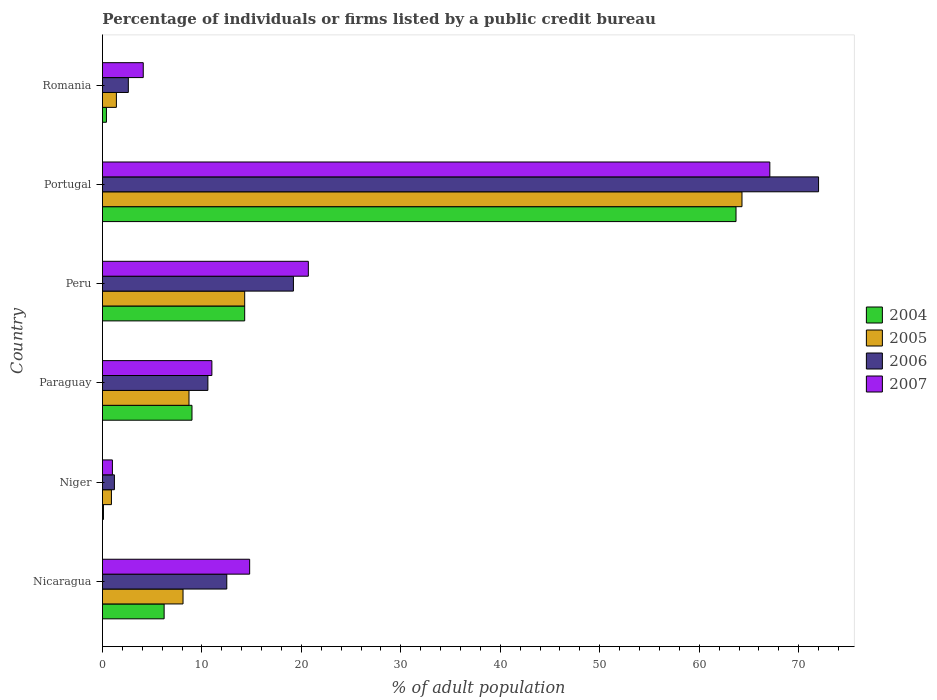How many different coloured bars are there?
Ensure brevity in your answer.  4. Are the number of bars on each tick of the Y-axis equal?
Offer a very short reply. Yes. How many bars are there on the 1st tick from the top?
Offer a terse response. 4. What is the label of the 6th group of bars from the top?
Offer a terse response. Nicaragua. In how many cases, is the number of bars for a given country not equal to the number of legend labels?
Offer a terse response. 0. What is the percentage of population listed by a public credit bureau in 2005 in Peru?
Your response must be concise. 14.3. In which country was the percentage of population listed by a public credit bureau in 2007 maximum?
Provide a succinct answer. Portugal. In which country was the percentage of population listed by a public credit bureau in 2004 minimum?
Make the answer very short. Niger. What is the total percentage of population listed by a public credit bureau in 2005 in the graph?
Provide a succinct answer. 97.7. What is the difference between the percentage of population listed by a public credit bureau in 2005 in Paraguay and that in Romania?
Make the answer very short. 7.3. What is the average percentage of population listed by a public credit bureau in 2006 per country?
Provide a succinct answer. 19.68. What is the difference between the percentage of population listed by a public credit bureau in 2007 and percentage of population listed by a public credit bureau in 2006 in Peru?
Your answer should be compact. 1.5. In how many countries, is the percentage of population listed by a public credit bureau in 2006 greater than 72 %?
Provide a succinct answer. 0. What is the ratio of the percentage of population listed by a public credit bureau in 2004 in Niger to that in Peru?
Your response must be concise. 0.01. What is the difference between the highest and the lowest percentage of population listed by a public credit bureau in 2005?
Ensure brevity in your answer.  63.4. How many bars are there?
Offer a very short reply. 24. Are all the bars in the graph horizontal?
Your answer should be compact. Yes. What is the difference between two consecutive major ticks on the X-axis?
Offer a terse response. 10. Are the values on the major ticks of X-axis written in scientific E-notation?
Your answer should be very brief. No. Does the graph contain any zero values?
Offer a terse response. No. Does the graph contain grids?
Your response must be concise. No. How many legend labels are there?
Make the answer very short. 4. How are the legend labels stacked?
Provide a succinct answer. Vertical. What is the title of the graph?
Your answer should be very brief. Percentage of individuals or firms listed by a public credit bureau. Does "1987" appear as one of the legend labels in the graph?
Ensure brevity in your answer.  No. What is the label or title of the X-axis?
Provide a short and direct response. % of adult population. What is the % of adult population in 2004 in Nicaragua?
Your answer should be very brief. 6.2. What is the % of adult population of 2005 in Nicaragua?
Give a very brief answer. 8.1. What is the % of adult population of 2007 in Nicaragua?
Your response must be concise. 14.8. What is the % of adult population in 2004 in Niger?
Make the answer very short. 0.1. What is the % of adult population of 2005 in Niger?
Ensure brevity in your answer.  0.9. What is the % of adult population in 2007 in Niger?
Give a very brief answer. 1. What is the % of adult population of 2007 in Paraguay?
Give a very brief answer. 11. What is the % of adult population of 2004 in Peru?
Offer a very short reply. 14.3. What is the % of adult population of 2005 in Peru?
Ensure brevity in your answer.  14.3. What is the % of adult population of 2007 in Peru?
Your answer should be compact. 20.7. What is the % of adult population of 2004 in Portugal?
Make the answer very short. 63.7. What is the % of adult population of 2005 in Portugal?
Make the answer very short. 64.3. What is the % of adult population of 2006 in Portugal?
Provide a short and direct response. 72. What is the % of adult population of 2007 in Portugal?
Your answer should be compact. 67.1. Across all countries, what is the maximum % of adult population of 2004?
Provide a succinct answer. 63.7. Across all countries, what is the maximum % of adult population of 2005?
Your answer should be very brief. 64.3. Across all countries, what is the maximum % of adult population in 2007?
Make the answer very short. 67.1. Across all countries, what is the minimum % of adult population in 2004?
Make the answer very short. 0.1. What is the total % of adult population in 2004 in the graph?
Provide a succinct answer. 93.7. What is the total % of adult population in 2005 in the graph?
Your answer should be very brief. 97.7. What is the total % of adult population of 2006 in the graph?
Offer a very short reply. 118.1. What is the total % of adult population in 2007 in the graph?
Your answer should be compact. 118.7. What is the difference between the % of adult population in 2005 in Nicaragua and that in Niger?
Your answer should be very brief. 7.2. What is the difference between the % of adult population of 2006 in Nicaragua and that in Niger?
Your answer should be compact. 11.3. What is the difference between the % of adult population in 2007 in Nicaragua and that in Niger?
Provide a short and direct response. 13.8. What is the difference between the % of adult population of 2004 in Nicaragua and that in Paraguay?
Your answer should be very brief. -2.8. What is the difference between the % of adult population in 2005 in Nicaragua and that in Paraguay?
Your response must be concise. -0.6. What is the difference between the % of adult population in 2006 in Nicaragua and that in Paraguay?
Your response must be concise. 1.9. What is the difference between the % of adult population in 2004 in Nicaragua and that in Peru?
Your answer should be very brief. -8.1. What is the difference between the % of adult population of 2006 in Nicaragua and that in Peru?
Your answer should be compact. -6.7. What is the difference between the % of adult population of 2004 in Nicaragua and that in Portugal?
Keep it short and to the point. -57.5. What is the difference between the % of adult population of 2005 in Nicaragua and that in Portugal?
Offer a very short reply. -56.2. What is the difference between the % of adult population in 2006 in Nicaragua and that in Portugal?
Make the answer very short. -59.5. What is the difference between the % of adult population in 2007 in Nicaragua and that in Portugal?
Give a very brief answer. -52.3. What is the difference between the % of adult population of 2004 in Nicaragua and that in Romania?
Ensure brevity in your answer.  5.8. What is the difference between the % of adult population of 2005 in Nicaragua and that in Romania?
Your response must be concise. 6.7. What is the difference between the % of adult population in 2006 in Nicaragua and that in Romania?
Your response must be concise. 9.9. What is the difference between the % of adult population of 2004 in Niger and that in Paraguay?
Give a very brief answer. -8.9. What is the difference between the % of adult population in 2006 in Niger and that in Paraguay?
Offer a terse response. -9.4. What is the difference between the % of adult population in 2006 in Niger and that in Peru?
Keep it short and to the point. -18. What is the difference between the % of adult population of 2007 in Niger and that in Peru?
Make the answer very short. -19.7. What is the difference between the % of adult population of 2004 in Niger and that in Portugal?
Provide a short and direct response. -63.6. What is the difference between the % of adult population of 2005 in Niger and that in Portugal?
Provide a succinct answer. -63.4. What is the difference between the % of adult population of 2006 in Niger and that in Portugal?
Ensure brevity in your answer.  -70.8. What is the difference between the % of adult population of 2007 in Niger and that in Portugal?
Keep it short and to the point. -66.1. What is the difference between the % of adult population in 2004 in Niger and that in Romania?
Offer a terse response. -0.3. What is the difference between the % of adult population in 2005 in Niger and that in Romania?
Make the answer very short. -0.5. What is the difference between the % of adult population in 2006 in Niger and that in Romania?
Ensure brevity in your answer.  -1.4. What is the difference between the % of adult population of 2007 in Niger and that in Romania?
Your answer should be very brief. -3.1. What is the difference between the % of adult population in 2006 in Paraguay and that in Peru?
Keep it short and to the point. -8.6. What is the difference between the % of adult population of 2007 in Paraguay and that in Peru?
Make the answer very short. -9.7. What is the difference between the % of adult population in 2004 in Paraguay and that in Portugal?
Make the answer very short. -54.7. What is the difference between the % of adult population in 2005 in Paraguay and that in Portugal?
Provide a succinct answer. -55.6. What is the difference between the % of adult population in 2006 in Paraguay and that in Portugal?
Give a very brief answer. -61.4. What is the difference between the % of adult population in 2007 in Paraguay and that in Portugal?
Keep it short and to the point. -56.1. What is the difference between the % of adult population of 2005 in Paraguay and that in Romania?
Your answer should be compact. 7.3. What is the difference between the % of adult population of 2007 in Paraguay and that in Romania?
Your response must be concise. 6.9. What is the difference between the % of adult population of 2004 in Peru and that in Portugal?
Offer a terse response. -49.4. What is the difference between the % of adult population in 2006 in Peru and that in Portugal?
Your answer should be compact. -52.8. What is the difference between the % of adult population of 2007 in Peru and that in Portugal?
Offer a terse response. -46.4. What is the difference between the % of adult population of 2005 in Peru and that in Romania?
Offer a terse response. 12.9. What is the difference between the % of adult population of 2007 in Peru and that in Romania?
Offer a very short reply. 16.6. What is the difference between the % of adult population in 2004 in Portugal and that in Romania?
Offer a very short reply. 63.3. What is the difference between the % of adult population of 2005 in Portugal and that in Romania?
Ensure brevity in your answer.  62.9. What is the difference between the % of adult population in 2006 in Portugal and that in Romania?
Offer a very short reply. 69.4. What is the difference between the % of adult population of 2004 in Nicaragua and the % of adult population of 2005 in Niger?
Offer a terse response. 5.3. What is the difference between the % of adult population of 2004 in Nicaragua and the % of adult population of 2006 in Niger?
Provide a succinct answer. 5. What is the difference between the % of adult population of 2004 in Nicaragua and the % of adult population of 2007 in Niger?
Your answer should be very brief. 5.2. What is the difference between the % of adult population of 2004 in Nicaragua and the % of adult population of 2005 in Paraguay?
Your response must be concise. -2.5. What is the difference between the % of adult population of 2004 in Nicaragua and the % of adult population of 2007 in Paraguay?
Ensure brevity in your answer.  -4.8. What is the difference between the % of adult population in 2005 in Nicaragua and the % of adult population in 2007 in Paraguay?
Offer a terse response. -2.9. What is the difference between the % of adult population of 2004 in Nicaragua and the % of adult population of 2005 in Peru?
Offer a very short reply. -8.1. What is the difference between the % of adult population of 2004 in Nicaragua and the % of adult population of 2006 in Peru?
Ensure brevity in your answer.  -13. What is the difference between the % of adult population of 2005 in Nicaragua and the % of adult population of 2006 in Peru?
Give a very brief answer. -11.1. What is the difference between the % of adult population in 2005 in Nicaragua and the % of adult population in 2007 in Peru?
Offer a very short reply. -12.6. What is the difference between the % of adult population in 2004 in Nicaragua and the % of adult population in 2005 in Portugal?
Provide a short and direct response. -58.1. What is the difference between the % of adult population of 2004 in Nicaragua and the % of adult population of 2006 in Portugal?
Offer a very short reply. -65.8. What is the difference between the % of adult population of 2004 in Nicaragua and the % of adult population of 2007 in Portugal?
Your response must be concise. -60.9. What is the difference between the % of adult population in 2005 in Nicaragua and the % of adult population in 2006 in Portugal?
Provide a short and direct response. -63.9. What is the difference between the % of adult population of 2005 in Nicaragua and the % of adult population of 2007 in Portugal?
Offer a terse response. -59. What is the difference between the % of adult population of 2006 in Nicaragua and the % of adult population of 2007 in Portugal?
Offer a terse response. -54.6. What is the difference between the % of adult population in 2004 in Nicaragua and the % of adult population in 2005 in Romania?
Your answer should be compact. 4.8. What is the difference between the % of adult population of 2005 in Nicaragua and the % of adult population of 2006 in Romania?
Offer a very short reply. 5.5. What is the difference between the % of adult population of 2005 in Nicaragua and the % of adult population of 2007 in Romania?
Give a very brief answer. 4. What is the difference between the % of adult population of 2006 in Nicaragua and the % of adult population of 2007 in Romania?
Offer a very short reply. 8.4. What is the difference between the % of adult population in 2004 in Niger and the % of adult population in 2006 in Paraguay?
Ensure brevity in your answer.  -10.5. What is the difference between the % of adult population of 2004 in Niger and the % of adult population of 2007 in Paraguay?
Offer a terse response. -10.9. What is the difference between the % of adult population in 2005 in Niger and the % of adult population in 2007 in Paraguay?
Provide a short and direct response. -10.1. What is the difference between the % of adult population in 2006 in Niger and the % of adult population in 2007 in Paraguay?
Your response must be concise. -9.8. What is the difference between the % of adult population in 2004 in Niger and the % of adult population in 2005 in Peru?
Provide a short and direct response. -14.2. What is the difference between the % of adult population of 2004 in Niger and the % of adult population of 2006 in Peru?
Offer a very short reply. -19.1. What is the difference between the % of adult population of 2004 in Niger and the % of adult population of 2007 in Peru?
Provide a succinct answer. -20.6. What is the difference between the % of adult population of 2005 in Niger and the % of adult population of 2006 in Peru?
Offer a terse response. -18.3. What is the difference between the % of adult population of 2005 in Niger and the % of adult population of 2007 in Peru?
Your response must be concise. -19.8. What is the difference between the % of adult population of 2006 in Niger and the % of adult population of 2007 in Peru?
Offer a very short reply. -19.5. What is the difference between the % of adult population of 2004 in Niger and the % of adult population of 2005 in Portugal?
Provide a short and direct response. -64.2. What is the difference between the % of adult population in 2004 in Niger and the % of adult population in 2006 in Portugal?
Ensure brevity in your answer.  -71.9. What is the difference between the % of adult population in 2004 in Niger and the % of adult population in 2007 in Portugal?
Your answer should be compact. -67. What is the difference between the % of adult population of 2005 in Niger and the % of adult population of 2006 in Portugal?
Keep it short and to the point. -71.1. What is the difference between the % of adult population in 2005 in Niger and the % of adult population in 2007 in Portugal?
Make the answer very short. -66.2. What is the difference between the % of adult population in 2006 in Niger and the % of adult population in 2007 in Portugal?
Ensure brevity in your answer.  -65.9. What is the difference between the % of adult population of 2004 in Niger and the % of adult population of 2007 in Romania?
Ensure brevity in your answer.  -4. What is the difference between the % of adult population of 2005 in Niger and the % of adult population of 2006 in Romania?
Keep it short and to the point. -1.7. What is the difference between the % of adult population of 2004 in Paraguay and the % of adult population of 2005 in Peru?
Your answer should be compact. -5.3. What is the difference between the % of adult population in 2005 in Paraguay and the % of adult population in 2007 in Peru?
Your answer should be very brief. -12. What is the difference between the % of adult population of 2006 in Paraguay and the % of adult population of 2007 in Peru?
Offer a very short reply. -10.1. What is the difference between the % of adult population in 2004 in Paraguay and the % of adult population in 2005 in Portugal?
Keep it short and to the point. -55.3. What is the difference between the % of adult population in 2004 in Paraguay and the % of adult population in 2006 in Portugal?
Your response must be concise. -63. What is the difference between the % of adult population of 2004 in Paraguay and the % of adult population of 2007 in Portugal?
Your answer should be very brief. -58.1. What is the difference between the % of adult population of 2005 in Paraguay and the % of adult population of 2006 in Portugal?
Make the answer very short. -63.3. What is the difference between the % of adult population in 2005 in Paraguay and the % of adult population in 2007 in Portugal?
Your answer should be compact. -58.4. What is the difference between the % of adult population of 2006 in Paraguay and the % of adult population of 2007 in Portugal?
Offer a very short reply. -56.5. What is the difference between the % of adult population of 2004 in Paraguay and the % of adult population of 2005 in Romania?
Ensure brevity in your answer.  7.6. What is the difference between the % of adult population in 2004 in Paraguay and the % of adult population in 2007 in Romania?
Offer a terse response. 4.9. What is the difference between the % of adult population of 2005 in Paraguay and the % of adult population of 2006 in Romania?
Provide a succinct answer. 6.1. What is the difference between the % of adult population in 2006 in Paraguay and the % of adult population in 2007 in Romania?
Give a very brief answer. 6.5. What is the difference between the % of adult population in 2004 in Peru and the % of adult population in 2005 in Portugal?
Provide a short and direct response. -50. What is the difference between the % of adult population of 2004 in Peru and the % of adult population of 2006 in Portugal?
Your answer should be compact. -57.7. What is the difference between the % of adult population in 2004 in Peru and the % of adult population in 2007 in Portugal?
Provide a short and direct response. -52.8. What is the difference between the % of adult population of 2005 in Peru and the % of adult population of 2006 in Portugal?
Ensure brevity in your answer.  -57.7. What is the difference between the % of adult population in 2005 in Peru and the % of adult population in 2007 in Portugal?
Offer a terse response. -52.8. What is the difference between the % of adult population in 2006 in Peru and the % of adult population in 2007 in Portugal?
Ensure brevity in your answer.  -47.9. What is the difference between the % of adult population in 2004 in Peru and the % of adult population in 2006 in Romania?
Provide a succinct answer. 11.7. What is the difference between the % of adult population of 2004 in Peru and the % of adult population of 2007 in Romania?
Provide a short and direct response. 10.2. What is the difference between the % of adult population in 2005 in Peru and the % of adult population in 2007 in Romania?
Keep it short and to the point. 10.2. What is the difference between the % of adult population of 2006 in Peru and the % of adult population of 2007 in Romania?
Offer a terse response. 15.1. What is the difference between the % of adult population of 2004 in Portugal and the % of adult population of 2005 in Romania?
Ensure brevity in your answer.  62.3. What is the difference between the % of adult population of 2004 in Portugal and the % of adult population of 2006 in Romania?
Offer a very short reply. 61.1. What is the difference between the % of adult population in 2004 in Portugal and the % of adult population in 2007 in Romania?
Ensure brevity in your answer.  59.6. What is the difference between the % of adult population in 2005 in Portugal and the % of adult population in 2006 in Romania?
Keep it short and to the point. 61.7. What is the difference between the % of adult population in 2005 in Portugal and the % of adult population in 2007 in Romania?
Offer a very short reply. 60.2. What is the difference between the % of adult population in 2006 in Portugal and the % of adult population in 2007 in Romania?
Offer a terse response. 67.9. What is the average % of adult population in 2004 per country?
Make the answer very short. 15.62. What is the average % of adult population in 2005 per country?
Provide a succinct answer. 16.28. What is the average % of adult population of 2006 per country?
Your answer should be very brief. 19.68. What is the average % of adult population in 2007 per country?
Provide a short and direct response. 19.78. What is the difference between the % of adult population of 2005 and % of adult population of 2006 in Nicaragua?
Make the answer very short. -4.4. What is the difference between the % of adult population in 2005 and % of adult population in 2007 in Nicaragua?
Ensure brevity in your answer.  -6.7. What is the difference between the % of adult population of 2006 and % of adult population of 2007 in Nicaragua?
Keep it short and to the point. -2.3. What is the difference between the % of adult population in 2004 and % of adult population in 2007 in Niger?
Ensure brevity in your answer.  -0.9. What is the difference between the % of adult population in 2004 and % of adult population in 2006 in Paraguay?
Your answer should be very brief. -1.6. What is the difference between the % of adult population of 2005 and % of adult population of 2006 in Paraguay?
Provide a short and direct response. -1.9. What is the difference between the % of adult population of 2005 and % of adult population of 2007 in Paraguay?
Keep it short and to the point. -2.3. What is the difference between the % of adult population in 2004 and % of adult population in 2007 in Peru?
Keep it short and to the point. -6.4. What is the difference between the % of adult population of 2005 and % of adult population of 2007 in Peru?
Give a very brief answer. -6.4. What is the difference between the % of adult population in 2006 and % of adult population in 2007 in Peru?
Your response must be concise. -1.5. What is the difference between the % of adult population in 2004 and % of adult population in 2005 in Portugal?
Provide a succinct answer. -0.6. What is the difference between the % of adult population of 2004 and % of adult population of 2006 in Portugal?
Give a very brief answer. -8.3. What is the difference between the % of adult population in 2004 and % of adult population in 2007 in Portugal?
Ensure brevity in your answer.  -3.4. What is the difference between the % of adult population in 2005 and % of adult population in 2006 in Portugal?
Provide a short and direct response. -7.7. What is the difference between the % of adult population in 2006 and % of adult population in 2007 in Portugal?
Your answer should be very brief. 4.9. What is the difference between the % of adult population of 2006 and % of adult population of 2007 in Romania?
Ensure brevity in your answer.  -1.5. What is the ratio of the % of adult population of 2004 in Nicaragua to that in Niger?
Provide a short and direct response. 62. What is the ratio of the % of adult population of 2006 in Nicaragua to that in Niger?
Your response must be concise. 10.42. What is the ratio of the % of adult population in 2007 in Nicaragua to that in Niger?
Provide a short and direct response. 14.8. What is the ratio of the % of adult population of 2004 in Nicaragua to that in Paraguay?
Keep it short and to the point. 0.69. What is the ratio of the % of adult population of 2006 in Nicaragua to that in Paraguay?
Your answer should be compact. 1.18. What is the ratio of the % of adult population of 2007 in Nicaragua to that in Paraguay?
Offer a very short reply. 1.35. What is the ratio of the % of adult population of 2004 in Nicaragua to that in Peru?
Provide a succinct answer. 0.43. What is the ratio of the % of adult population in 2005 in Nicaragua to that in Peru?
Provide a short and direct response. 0.57. What is the ratio of the % of adult population of 2006 in Nicaragua to that in Peru?
Your answer should be very brief. 0.65. What is the ratio of the % of adult population in 2007 in Nicaragua to that in Peru?
Give a very brief answer. 0.71. What is the ratio of the % of adult population in 2004 in Nicaragua to that in Portugal?
Offer a terse response. 0.1. What is the ratio of the % of adult population of 2005 in Nicaragua to that in Portugal?
Keep it short and to the point. 0.13. What is the ratio of the % of adult population in 2006 in Nicaragua to that in Portugal?
Give a very brief answer. 0.17. What is the ratio of the % of adult population of 2007 in Nicaragua to that in Portugal?
Provide a short and direct response. 0.22. What is the ratio of the % of adult population of 2004 in Nicaragua to that in Romania?
Provide a short and direct response. 15.5. What is the ratio of the % of adult population in 2005 in Nicaragua to that in Romania?
Keep it short and to the point. 5.79. What is the ratio of the % of adult population of 2006 in Nicaragua to that in Romania?
Ensure brevity in your answer.  4.81. What is the ratio of the % of adult population of 2007 in Nicaragua to that in Romania?
Keep it short and to the point. 3.61. What is the ratio of the % of adult population in 2004 in Niger to that in Paraguay?
Your response must be concise. 0.01. What is the ratio of the % of adult population of 2005 in Niger to that in Paraguay?
Keep it short and to the point. 0.1. What is the ratio of the % of adult population of 2006 in Niger to that in Paraguay?
Provide a short and direct response. 0.11. What is the ratio of the % of adult population in 2007 in Niger to that in Paraguay?
Offer a very short reply. 0.09. What is the ratio of the % of adult population in 2004 in Niger to that in Peru?
Ensure brevity in your answer.  0.01. What is the ratio of the % of adult population in 2005 in Niger to that in Peru?
Ensure brevity in your answer.  0.06. What is the ratio of the % of adult population of 2006 in Niger to that in Peru?
Give a very brief answer. 0.06. What is the ratio of the % of adult population of 2007 in Niger to that in Peru?
Your answer should be compact. 0.05. What is the ratio of the % of adult population of 2004 in Niger to that in Portugal?
Provide a short and direct response. 0. What is the ratio of the % of adult population in 2005 in Niger to that in Portugal?
Make the answer very short. 0.01. What is the ratio of the % of adult population of 2006 in Niger to that in Portugal?
Provide a short and direct response. 0.02. What is the ratio of the % of adult population in 2007 in Niger to that in Portugal?
Provide a succinct answer. 0.01. What is the ratio of the % of adult population of 2005 in Niger to that in Romania?
Ensure brevity in your answer.  0.64. What is the ratio of the % of adult population of 2006 in Niger to that in Romania?
Provide a succinct answer. 0.46. What is the ratio of the % of adult population in 2007 in Niger to that in Romania?
Ensure brevity in your answer.  0.24. What is the ratio of the % of adult population of 2004 in Paraguay to that in Peru?
Provide a succinct answer. 0.63. What is the ratio of the % of adult population of 2005 in Paraguay to that in Peru?
Ensure brevity in your answer.  0.61. What is the ratio of the % of adult population in 2006 in Paraguay to that in Peru?
Make the answer very short. 0.55. What is the ratio of the % of adult population in 2007 in Paraguay to that in Peru?
Make the answer very short. 0.53. What is the ratio of the % of adult population of 2004 in Paraguay to that in Portugal?
Provide a succinct answer. 0.14. What is the ratio of the % of adult population of 2005 in Paraguay to that in Portugal?
Your answer should be compact. 0.14. What is the ratio of the % of adult population in 2006 in Paraguay to that in Portugal?
Provide a succinct answer. 0.15. What is the ratio of the % of adult population in 2007 in Paraguay to that in Portugal?
Your response must be concise. 0.16. What is the ratio of the % of adult population of 2004 in Paraguay to that in Romania?
Offer a very short reply. 22.5. What is the ratio of the % of adult population of 2005 in Paraguay to that in Romania?
Provide a succinct answer. 6.21. What is the ratio of the % of adult population of 2006 in Paraguay to that in Romania?
Keep it short and to the point. 4.08. What is the ratio of the % of adult population of 2007 in Paraguay to that in Romania?
Your response must be concise. 2.68. What is the ratio of the % of adult population of 2004 in Peru to that in Portugal?
Your response must be concise. 0.22. What is the ratio of the % of adult population in 2005 in Peru to that in Portugal?
Offer a very short reply. 0.22. What is the ratio of the % of adult population in 2006 in Peru to that in Portugal?
Keep it short and to the point. 0.27. What is the ratio of the % of adult population in 2007 in Peru to that in Portugal?
Keep it short and to the point. 0.31. What is the ratio of the % of adult population in 2004 in Peru to that in Romania?
Your answer should be compact. 35.75. What is the ratio of the % of adult population of 2005 in Peru to that in Romania?
Offer a terse response. 10.21. What is the ratio of the % of adult population in 2006 in Peru to that in Romania?
Provide a short and direct response. 7.38. What is the ratio of the % of adult population in 2007 in Peru to that in Romania?
Offer a terse response. 5.05. What is the ratio of the % of adult population of 2004 in Portugal to that in Romania?
Ensure brevity in your answer.  159.25. What is the ratio of the % of adult population in 2005 in Portugal to that in Romania?
Your answer should be compact. 45.93. What is the ratio of the % of adult population of 2006 in Portugal to that in Romania?
Make the answer very short. 27.69. What is the ratio of the % of adult population of 2007 in Portugal to that in Romania?
Your answer should be very brief. 16.37. What is the difference between the highest and the second highest % of adult population of 2004?
Provide a short and direct response. 49.4. What is the difference between the highest and the second highest % of adult population of 2006?
Give a very brief answer. 52.8. What is the difference between the highest and the second highest % of adult population of 2007?
Provide a succinct answer. 46.4. What is the difference between the highest and the lowest % of adult population of 2004?
Offer a very short reply. 63.6. What is the difference between the highest and the lowest % of adult population in 2005?
Your response must be concise. 63.4. What is the difference between the highest and the lowest % of adult population in 2006?
Offer a terse response. 70.8. What is the difference between the highest and the lowest % of adult population of 2007?
Your answer should be very brief. 66.1. 